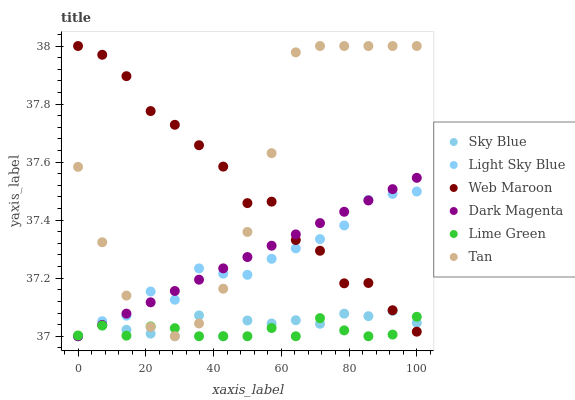Does Lime Green have the minimum area under the curve?
Answer yes or no. Yes. Does Tan have the maximum area under the curve?
Answer yes or no. Yes. Does Web Maroon have the minimum area under the curve?
Answer yes or no. No. Does Web Maroon have the maximum area under the curve?
Answer yes or no. No. Is Dark Magenta the smoothest?
Answer yes or no. Yes. Is Tan the roughest?
Answer yes or no. Yes. Is Web Maroon the smoothest?
Answer yes or no. No. Is Web Maroon the roughest?
Answer yes or no. No. Does Dark Magenta have the lowest value?
Answer yes or no. Yes. Does Web Maroon have the lowest value?
Answer yes or no. No. Does Tan have the highest value?
Answer yes or no. Yes. Does Light Sky Blue have the highest value?
Answer yes or no. No. Does Light Sky Blue intersect Tan?
Answer yes or no. Yes. Is Light Sky Blue less than Tan?
Answer yes or no. No. Is Light Sky Blue greater than Tan?
Answer yes or no. No. 